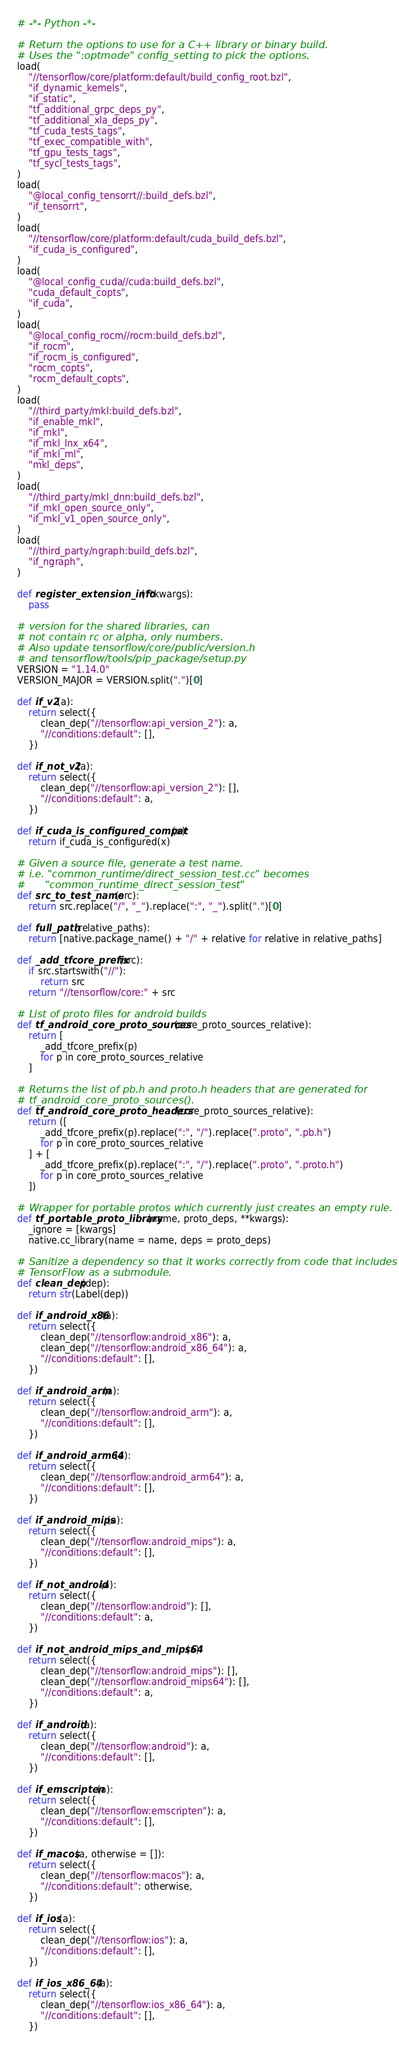Convert code to text. <code><loc_0><loc_0><loc_500><loc_500><_Python_># -*- Python -*-

# Return the options to use for a C++ library or binary build.
# Uses the ":optmode" config_setting to pick the options.
load(
    "//tensorflow/core/platform:default/build_config_root.bzl",
    "if_dynamic_kernels",
    "if_static",
    "tf_additional_grpc_deps_py",
    "tf_additional_xla_deps_py",
    "tf_cuda_tests_tags",
    "tf_exec_compatible_with",
    "tf_gpu_tests_tags",
    "tf_sycl_tests_tags",
)
load(
    "@local_config_tensorrt//:build_defs.bzl",
    "if_tensorrt",
)
load(
    "//tensorflow/core/platform:default/cuda_build_defs.bzl",
    "if_cuda_is_configured",
)
load(
    "@local_config_cuda//cuda:build_defs.bzl",
    "cuda_default_copts",
    "if_cuda",
)
load(
    "@local_config_rocm//rocm:build_defs.bzl",
    "if_rocm",
    "if_rocm_is_configured",
    "rocm_copts",
    "rocm_default_copts",
)
load(
    "//third_party/mkl:build_defs.bzl",
    "if_enable_mkl",
    "if_mkl",
    "if_mkl_lnx_x64",
    "if_mkl_ml",
    "mkl_deps",
)
load(
    "//third_party/mkl_dnn:build_defs.bzl",
    "if_mkl_open_source_only",
    "if_mkl_v1_open_source_only",
)
load(
    "//third_party/ngraph:build_defs.bzl",
    "if_ngraph",
)

def register_extension_info(**kwargs):
    pass

# version for the shared libraries, can
# not contain rc or alpha, only numbers.
# Also update tensorflow/core/public/version.h
# and tensorflow/tools/pip_package/setup.py
VERSION = "1.14.0"
VERSION_MAJOR = VERSION.split(".")[0]

def if_v2(a):
    return select({
        clean_dep("//tensorflow:api_version_2"): a,
        "//conditions:default": [],
    })

def if_not_v2(a):
    return select({
        clean_dep("//tensorflow:api_version_2"): [],
        "//conditions:default": a,
    })

def if_cuda_is_configured_compat(x):
    return if_cuda_is_configured(x)

# Given a source file, generate a test name.
# i.e. "common_runtime/direct_session_test.cc" becomes
#      "common_runtime_direct_session_test"
def src_to_test_name(src):
    return src.replace("/", "_").replace(":", "_").split(".")[0]

def full_path(relative_paths):
    return [native.package_name() + "/" + relative for relative in relative_paths]

def _add_tfcore_prefix(src):
    if src.startswith("//"):
        return src
    return "//tensorflow/core:" + src

# List of proto files for android builds
def tf_android_core_proto_sources(core_proto_sources_relative):
    return [
        _add_tfcore_prefix(p)
        for p in core_proto_sources_relative
    ]

# Returns the list of pb.h and proto.h headers that are generated for
# tf_android_core_proto_sources().
def tf_android_core_proto_headers(core_proto_sources_relative):
    return ([
        _add_tfcore_prefix(p).replace(":", "/").replace(".proto", ".pb.h")
        for p in core_proto_sources_relative
    ] + [
        _add_tfcore_prefix(p).replace(":", "/").replace(".proto", ".proto.h")
        for p in core_proto_sources_relative
    ])

# Wrapper for portable protos which currently just creates an empty rule.
def tf_portable_proto_library(name, proto_deps, **kwargs):
    _ignore = [kwargs]
    native.cc_library(name = name, deps = proto_deps)

# Sanitize a dependency so that it works correctly from code that includes
# TensorFlow as a submodule.
def clean_dep(dep):
    return str(Label(dep))

def if_android_x86(a):
    return select({
        clean_dep("//tensorflow:android_x86"): a,
        clean_dep("//tensorflow:android_x86_64"): a,
        "//conditions:default": [],
    })

def if_android_arm(a):
    return select({
        clean_dep("//tensorflow:android_arm"): a,
        "//conditions:default": [],
    })

def if_android_arm64(a):
    return select({
        clean_dep("//tensorflow:android_arm64"): a,
        "//conditions:default": [],
    })

def if_android_mips(a):
    return select({
        clean_dep("//tensorflow:android_mips"): a,
        "//conditions:default": [],
    })

def if_not_android(a):
    return select({
        clean_dep("//tensorflow:android"): [],
        "//conditions:default": a,
    })

def if_not_android_mips_and_mips64(a):
    return select({
        clean_dep("//tensorflow:android_mips"): [],
        clean_dep("//tensorflow:android_mips64"): [],
        "//conditions:default": a,
    })

def if_android(a):
    return select({
        clean_dep("//tensorflow:android"): a,
        "//conditions:default": [],
    })

def if_emscripten(a):
    return select({
        clean_dep("//tensorflow:emscripten"): a,
        "//conditions:default": [],
    })

def if_macos(a, otherwise = []):
    return select({
        clean_dep("//tensorflow:macos"): a,
        "//conditions:default": otherwise,
    })

def if_ios(a):
    return select({
        clean_dep("//tensorflow:ios"): a,
        "//conditions:default": [],
    })

def if_ios_x86_64(a):
    return select({
        clean_dep("//tensorflow:ios_x86_64"): a,
        "//conditions:default": [],
    })
</code> 